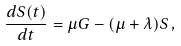<formula> <loc_0><loc_0><loc_500><loc_500>\frac { d S ( t ) } { d t } = \mu G - ( \mu + \lambda ) S \, ,</formula> 